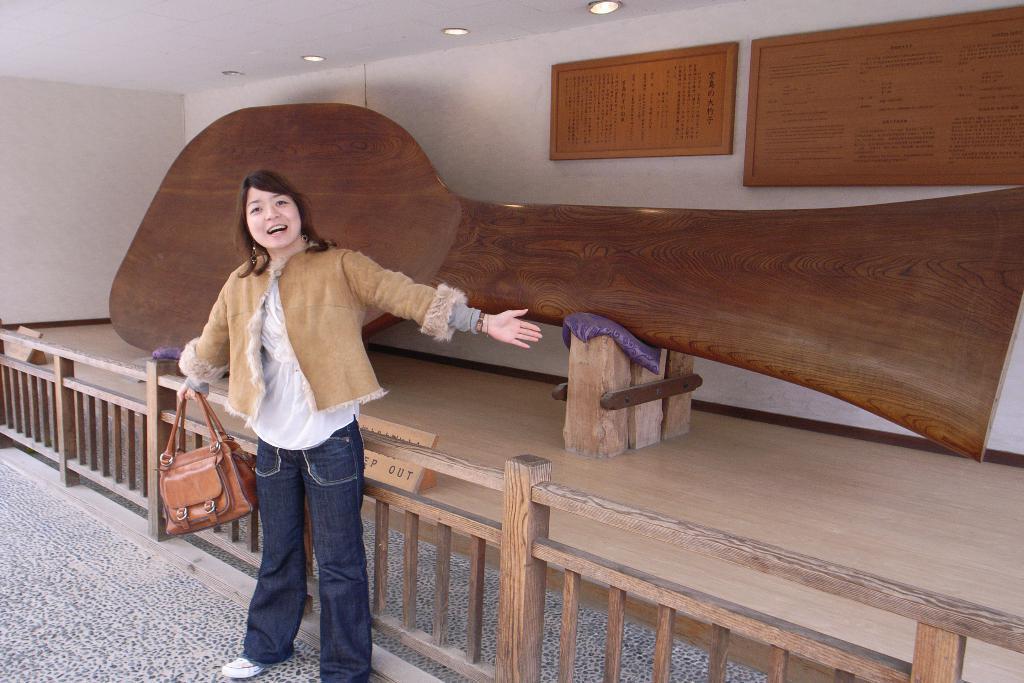Can you describe this image briefly? This picture shows a woman standing by holding a hand bag in her hand and we see a smile on her face and we see a wooden fence. 